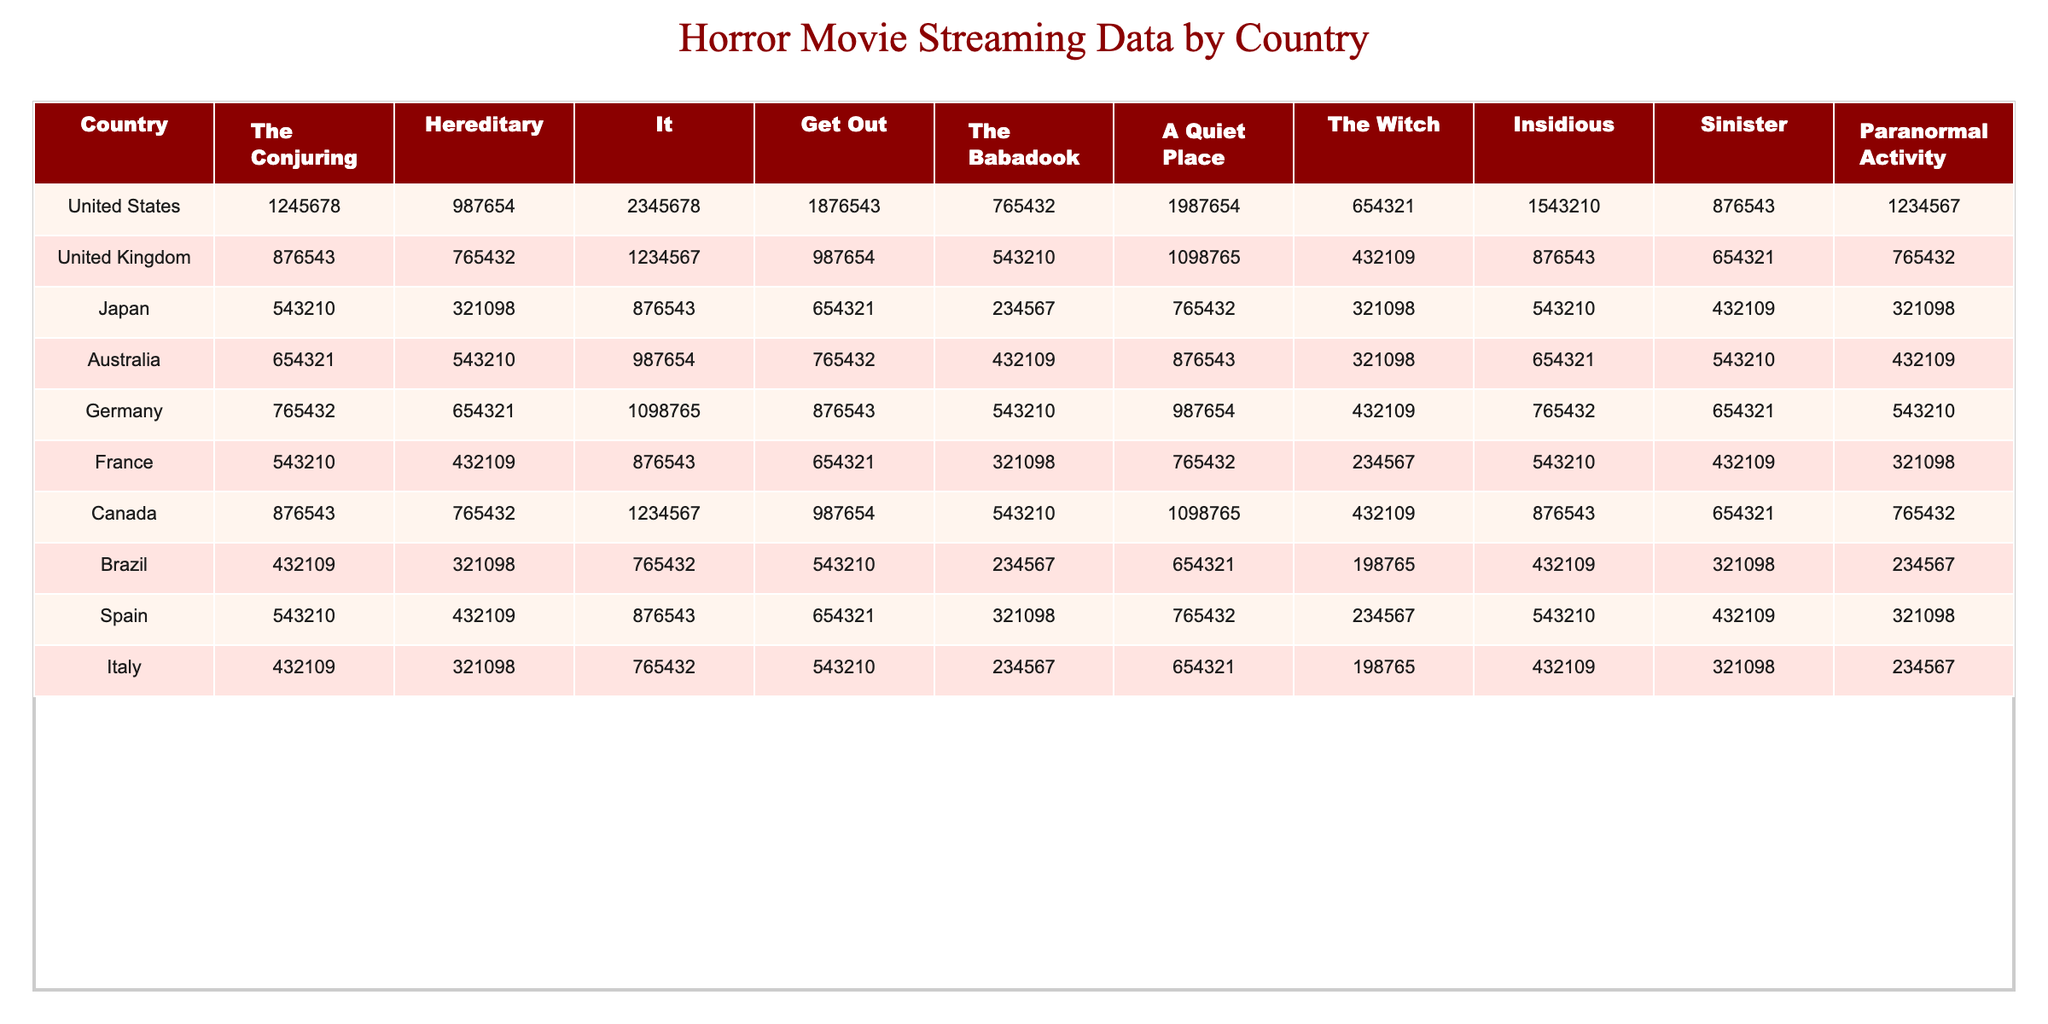What country has the highest view count for "It"? The highest view count for "It" is in the United States, with 2,345,678 views.
Answer: United States Which movie has the least views in the United Kingdom? In the United Kingdom, the movie with the least views is "The Babadook," which has 543,210 views.
Answer: The Babadook What is the total view count for "A Quiet Place" across all countries? The total view count for "A Quiet Place" is calculated by adding the views from each country: 1,987,654 + 1,098,765 + 765,432 + 876,543 + 987,654 + 765,432 + 654,321 + 654,321 + 543,210 + 654,321 = 8,239,891.
Answer: 8,239,891 Which two movies have the same number of views in Japan? In Japan, "Get Out" and "Paranormal Activity" both have 654,321 views.
Answer: Get Out and Paranormal Activity How many views does "The Conjuring" have in Brazil compared to Canada? "The Conjuring" has 432,109 views in Brazil and 876,543 views in Canada. The difference is 876,543 - 432,109 = 444,434 views more in Canada.
Answer: 444,434 Is "Sinister" the most-watched movie in any country? No, "Sinister" is not the most-watched movie in any country; the highest view counts in each country are held by different titles.
Answer: No What is the average view count of "The Witch" across all listed countries? To compute the average, first sum the views for "The Witch": 654,321 + 432,109 + 321,098 + 321,098 + 432,109 + 234,567 + 198,765 + 234,567 + 198,765 = 2,803,000. There are 10 countries, so the average is 2,803,000 / 10 = 280,300.
Answer: 280,300 Which country saw more views for "Hereditary," Canada or Germany? "Hereditary" has 765,432 views in Canada and 654,321 views in Germany. Thus, Canada has 111,111 more views.
Answer: Canada If we consider the top three titles with the highest view count in Italy, which are they? The top three titles in Italy are "It" (765,432 views), "Get Out" (543,210 views), and "A Quiet Place" (654,321 views), ordered by their views.
Answer: It, A Quiet Place, Get Out Which country has the most total views for "The Babadook"? The country with the most views for "The Babadook" is the United States, with 765,432 views.
Answer: United States 